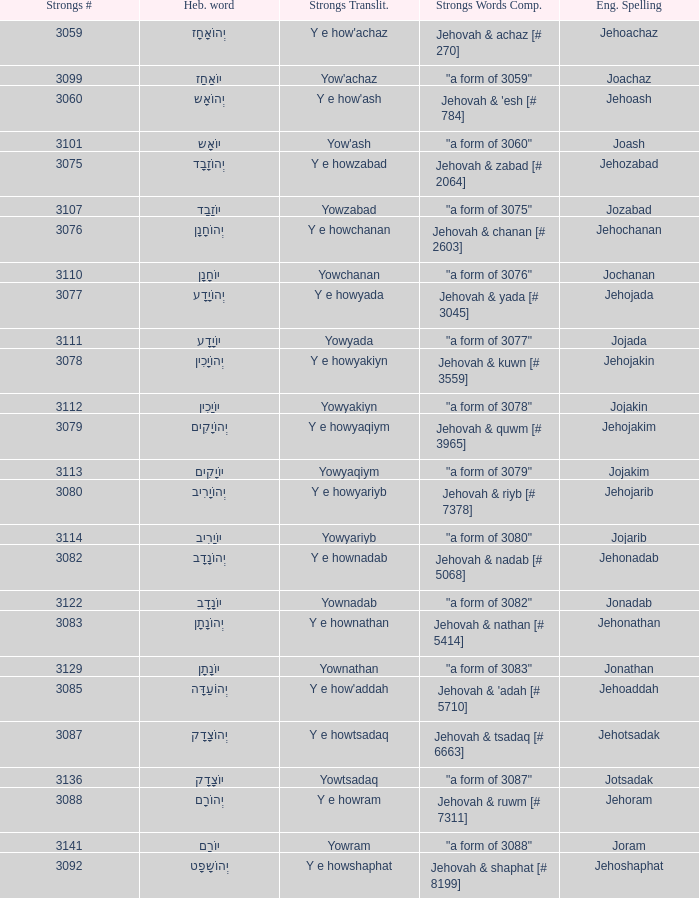What is the strong words compounded when the strongs transliteration is yowyariyb? "a form of 3080". 